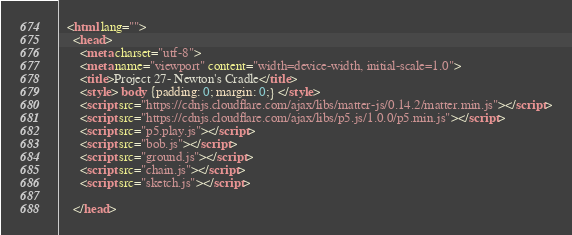Convert code to text. <code><loc_0><loc_0><loc_500><loc_500><_HTML_>  <html lang="">
    <head>
      <meta charset="utf-8">
      <meta name="viewport" content="width=device-width, initial-scale=1.0">
      <title>Project 27- Newton's Cradle</title>
      <style> body {padding: 0; margin: 0;} </style>
      <script src="https://cdnjs.cloudflare.com/ajax/libs/matter-js/0.14.2/matter.min.js"></script>
      <script src="https://cdnjs.cloudflare.com/ajax/libs/p5.js/1.0.0/p5.min.js"></script>
      <script src="p5.play.js"></script>
      <script src="bob.js"></script>
      <script src="ground.js"></script>
      <script src="chain.js"></script>
      <script src="sketch.js"></script>

    </head></code> 